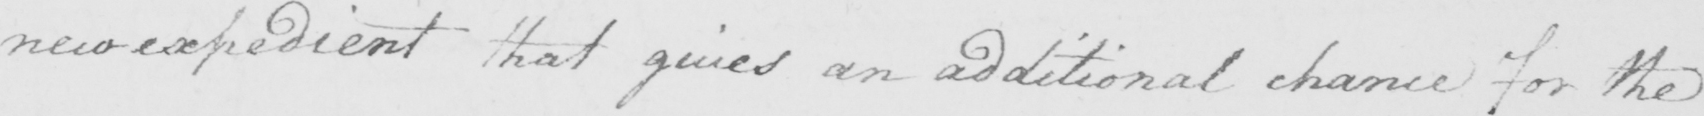Please transcribe the handwritten text in this image. new expedient that gives an additional chance for the 